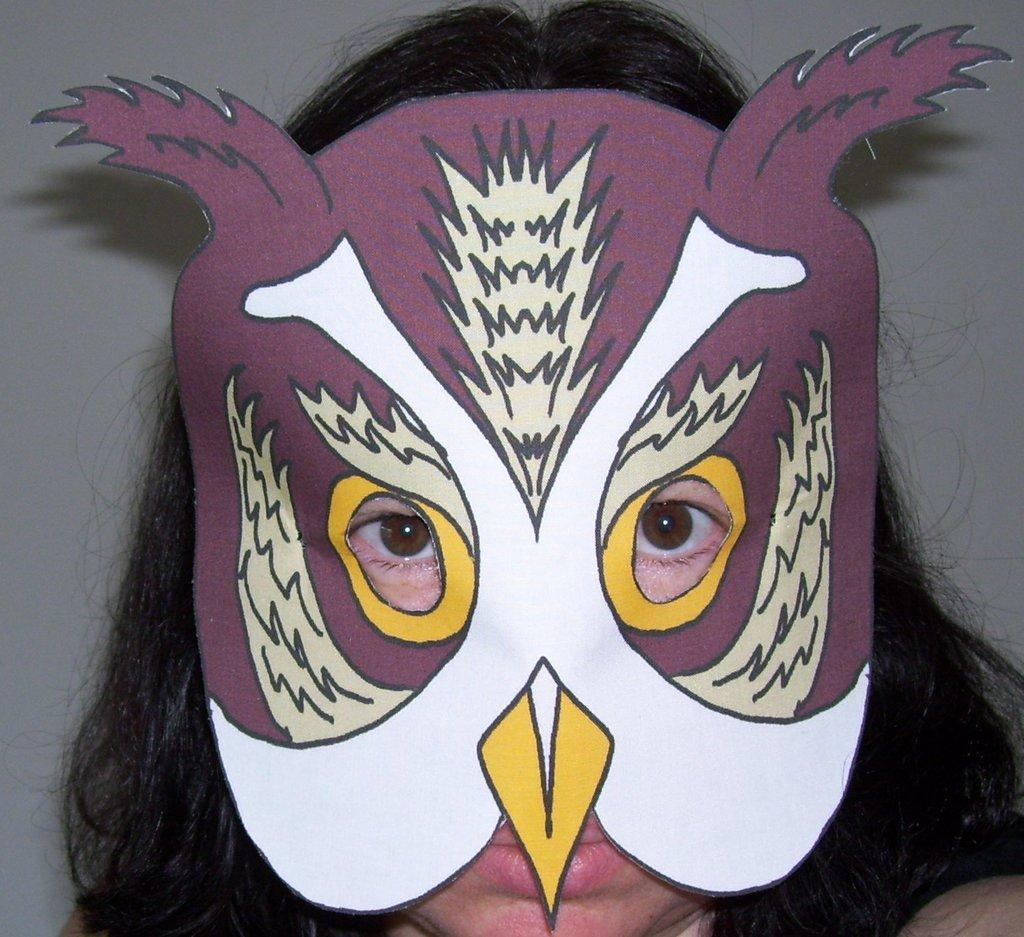What is the main subject of the image? There is a person in the image. Can you describe what the person is wearing? The person is wearing a mask. What can be seen in the background of the image? There is a wall in the background of the image. What type of sail can be seen in the image? There is no sail present in the image. What kind of pleasure can be experienced by the person in the image? The image does not provide information about the person's emotions or experiences, so it cannot be determined from the picture. 